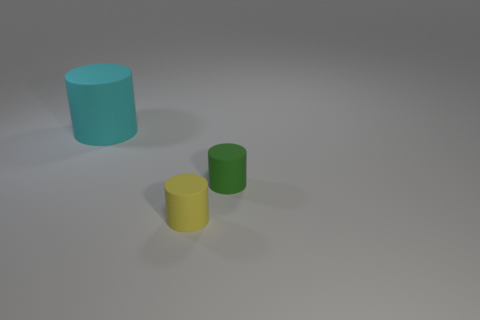Is there any distinguishing feature about the surface on which the objects are placed? The surface on which the objects are placed appears to be relatively smooth and featureless, with a subtle gradient of light suggesting it might be illuminated unevenly, possibly indicative of a simple and plain background commonly used in product photography or 3D modeling. 